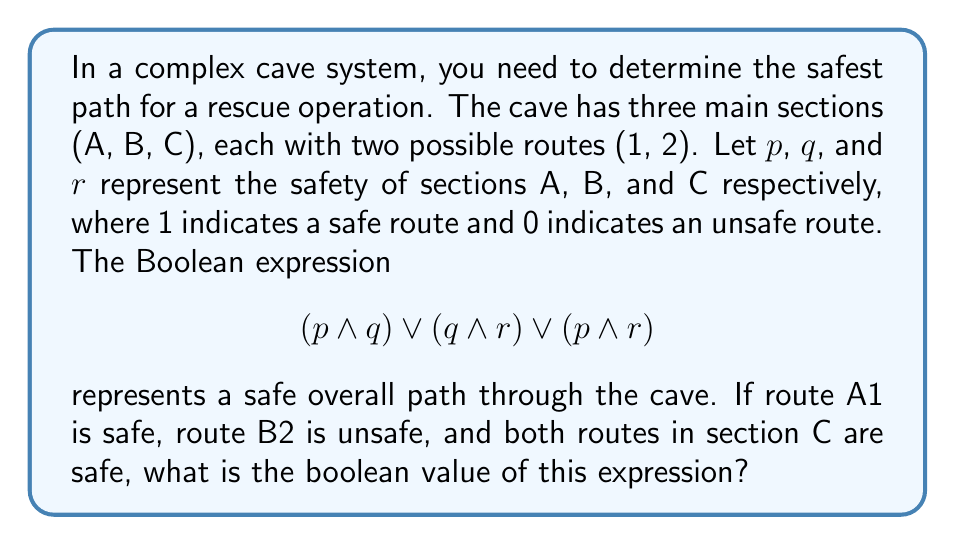Show me your answer to this math problem. Let's approach this step-by-step:

1) Given information:
   - Route A1 is safe, so $p = 1$
   - Route B2 is unsafe, but we don't know about B1, so $q$ is unknown
   - Both routes in C are safe, so $r = 1$

2) We need to evaluate $$(p \wedge q) \vee (q \wedge r) \vee (p \wedge r)$$

3) Let's substitute the known values:
   $$(1 \wedge q) \vee (q \wedge 1) \vee (1 \wedge 1)$$

4) Simplify the last term:
   $$(1 \wedge q) \vee (q \wedge 1) \vee 1$$

5) In Boolean algebra, $x \wedge 1 = x$ for any $x$, so we can simplify:
   $$q \vee q \vee 1$$

6) The $\vee$ (OR) operation with 1 always results in 1, regardless of the other operand:
   $$1$$

Therefore, regardless of the value of $q$ (the safety of section B), the overall expression evaluates to 1, indicating a safe path exists.
Answer: 1 